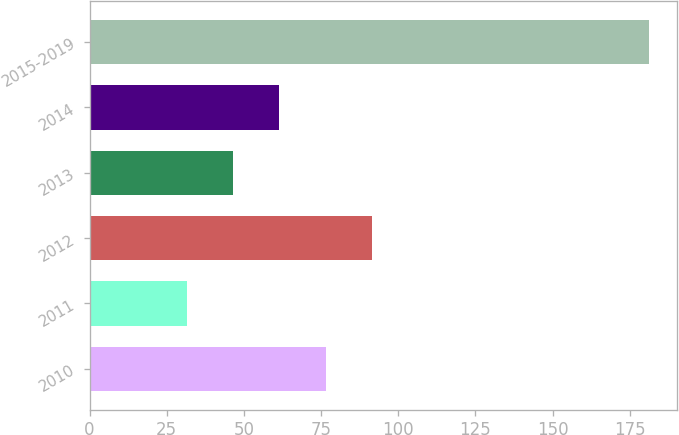<chart> <loc_0><loc_0><loc_500><loc_500><bar_chart><fcel>2010<fcel>2011<fcel>2012<fcel>2013<fcel>2014<fcel>2015-2019<nl><fcel>76.48<fcel>31.6<fcel>91.44<fcel>46.56<fcel>61.52<fcel>181.2<nl></chart> 